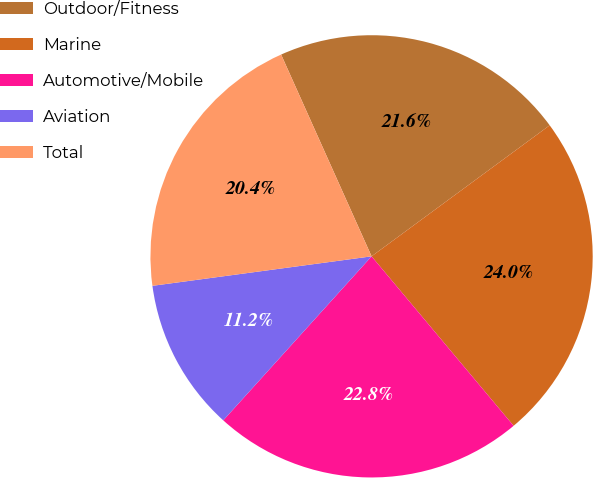Convert chart to OTSL. <chart><loc_0><loc_0><loc_500><loc_500><pie_chart><fcel>Outdoor/Fitness<fcel>Marine<fcel>Automotive/Mobile<fcel>Aviation<fcel>Total<nl><fcel>21.61%<fcel>23.99%<fcel>22.8%<fcel>11.17%<fcel>20.42%<nl></chart> 